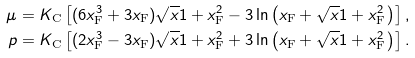Convert formula to latex. <formula><loc_0><loc_0><loc_500><loc_500>\mu & = K _ { \text  C}\left[(6x_{\text  F}^{3}+3x_{\text  F})\sqrt{x}{1+x_{\text  F} ^ { 2 } } - 3 \ln \left ( x _ { \text  F}+\sqrt{x}{1+x_{\text  F} ^ { 2 } } \, \right ) \right ] , \\ p & = K _ { \text  C}\left[(2x_{\text  F}^{3}-3x_{\text  F})\sqrt{x}{1+x_{\text  F} ^ { 2 } } + 3 \ln \left ( x _ { \text  F}+\sqrt{x}{1+x_{\text  F} ^ { 2 } } \, \right ) \right ] .</formula> 